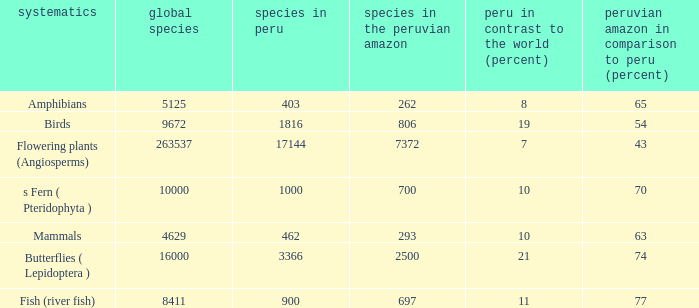Parse the full table. {'header': ['systematics', 'global species', 'species in peru', 'species in the peruvian amazon', 'peru in contrast to the world (percent)', 'peruvian amazon in comparison to peru (percent)'], 'rows': [['Amphibians', '5125', '403', '262', '8', '65'], ['Birds', '9672', '1816', '806', '19', '54'], ['Flowering plants (Angiosperms)', '263537', '17144', '7372', '7', '43'], ['s Fern ( Pteridophyta )', '10000', '1000', '700', '10', '70'], ['Mammals', '4629', '462', '293', '10', '63'], ['Butterflies ( Lepidoptera )', '16000', '3366', '2500', '21', '74'], ['Fish (river fish)', '8411', '900', '697', '11', '77']]} What's the minimum species in the peruvian amazon with species in peru of 1000 700.0. 